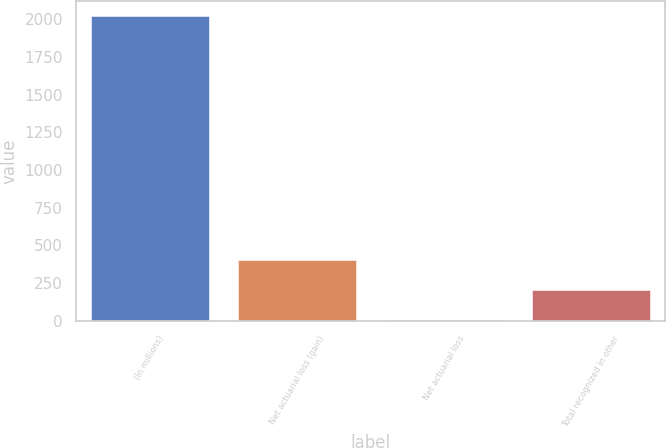Convert chart to OTSL. <chart><loc_0><loc_0><loc_500><loc_500><bar_chart><fcel>(In millions)<fcel>Net actuarial loss (gain)<fcel>Net actuarial loss<fcel>Total recognized in other<nl><fcel>2017<fcel>406.6<fcel>4<fcel>205.3<nl></chart> 